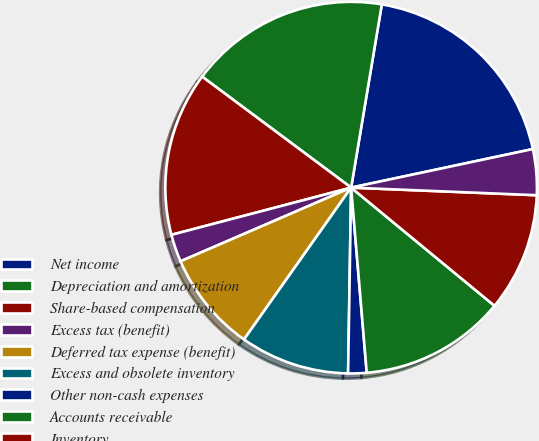Convert chart to OTSL. <chart><loc_0><loc_0><loc_500><loc_500><pie_chart><fcel>Net income<fcel>Depreciation and amortization<fcel>Share-based compensation<fcel>Excess tax (benefit)<fcel>Deferred tax expense (benefit)<fcel>Excess and obsolete inventory<fcel>Other non-cash expenses<fcel>Accounts receivable<fcel>Inventory<fcel>Accounts payable<nl><fcel>19.03%<fcel>17.45%<fcel>14.28%<fcel>2.4%<fcel>8.73%<fcel>9.52%<fcel>1.6%<fcel>12.69%<fcel>10.32%<fcel>3.98%<nl></chart> 